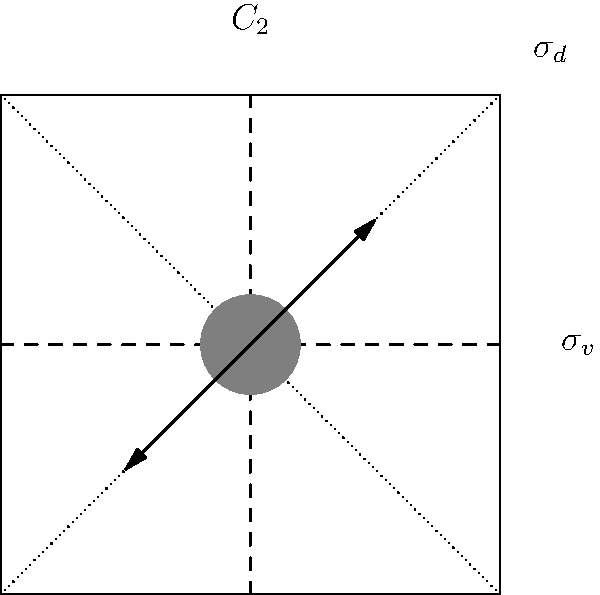Consider the crystal structure of an organic material shown above, which exhibits $C_{2v}$ point group symmetry. How would the presence of a $C_2$ rotation axis affect the dipole moment of the molecules within this structure, and what implications might this have for the material's dielectric properties? To answer this question, let's break it down step-by-step:

1. Symmetry elements: The crystal structure shows a $C_2$ rotation axis (vertical dashed line), two mirror planes $\sigma_v$ (vertical dashed line) and $\sigma_d$ (diagonal dotted lines), characteristic of the $C_{2v}$ point group.

2. $C_2$ rotation axis: This symmetry element represents a 180° rotation about the vertical axis.

3. Effect on dipole moment:
   a. For a molecule to have a non-zero dipole moment along the $C_2$ axis, it must be invariant under the $C_2$ operation.
   b. The arrows in the diagram represent the dipole moment of a molecule. Under $C_2$ rotation, these arrows would point in opposite directions.
   c. Therefore, any component of the dipole moment perpendicular to the $C_2$ axis would be canceled out by the rotation.
   d. However, a component parallel to the $C_2$ axis would remain unchanged.

4. Implications for dielectric properties:
   a. Dielectric properties are influenced by the ability of molecules to align with an applied electric field.
   b. The presence of a net dipole moment along the $C_2$ axis means the material can respond to an electric field applied in this direction.
   c. This would result in anisotropic dielectric behavior, where the material's response to an electric field depends on the field's orientation relative to the crystal structure.
   d. The material would likely exhibit a higher dielectric constant and stronger polarization response along the direction of the $C_2$ axis compared to perpendicular directions.

5. Overall effect:
   The $C_2$ rotation axis constrains the dipole moment to lie along this axis, leading to anisotropic dielectric properties in the crystal structure.
Answer: The $C_2$ axis constrains molecular dipoles along its direction, causing anisotropic dielectric properties. 